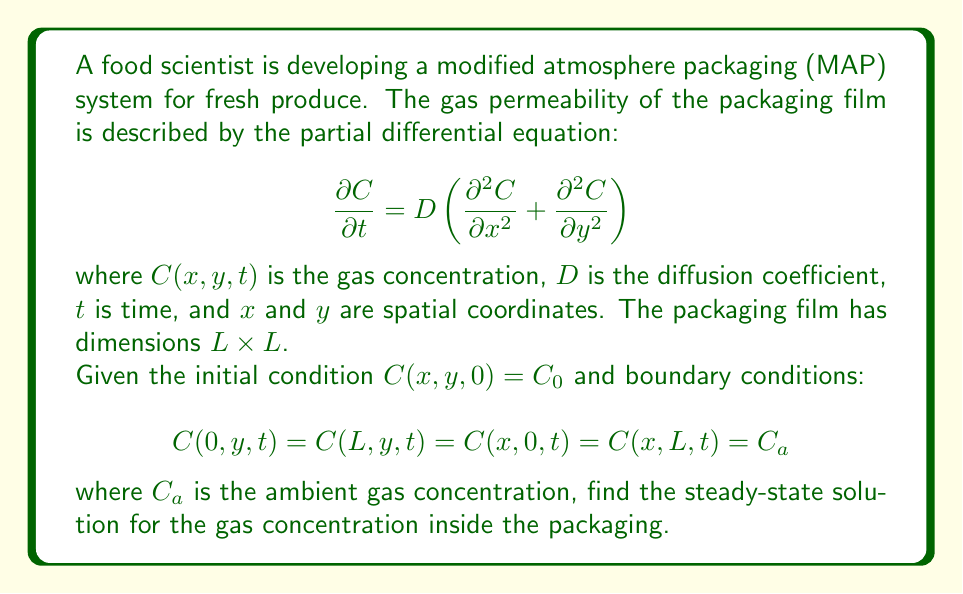Can you solve this math problem? To solve this problem, we need to follow these steps:

1) First, we recognize that we're looking for the steady-state solution. This means that the concentration doesn't change with time, so $\frac{\partial C}{\partial t} = 0$.

2) With this, our PDE reduces to:

   $$0 = D \left(\frac{\partial^2 C}{\partial x^2} + \frac{\partial^2 C}{\partial y^2}\right)$$

   or simply:

   $$\frac{\partial^2 C}{\partial x^2} + \frac{\partial^2 C}{\partial y^2} = 0$$

   This is the Laplace equation in two dimensions.

3) Given the boundary conditions, which are the same on all sides of the square packaging, we can use the method of separation of variables.

4) We assume a solution of the form $C(x,y) = X(x)Y(y)$.

5) Substituting this into our equation:

   $$X''(x)Y(y) + X(x)Y''(y) = 0$$

6) Dividing by $X(x)Y(y)$:

   $$\frac{X''(x)}{X(x)} + \frac{Y''(y)}{Y(y)} = 0$$

7) For this to be true for all $x$ and $y$, both terms must be constant. Let's call this constant $-k^2$:

   $$\frac{X''(x)}{X(x)} = -k^2, \quad \frac{Y''(y)}{Y(y)} = k^2$$

8) These lead to the general solutions:

   $$X(x) = A \cos(kx) + B \sin(kx)$$
   $$Y(y) = C \cosh(ky) + D \sinh(ky)$$

9) Applying the boundary conditions:

   At $x = 0$ and $x = L$: $C(0,y) = C(L,y) = C_a$
   At $y = 0$ and $y = L$: $C(x,0) = C(x,L) = C_a$

10) These conditions are satisfied when $k = 0$, which simplifies our solution to:

    $$C(x,y) = \text{constant} = C_a$$

Therefore, the steady-state solution is a constant concentration equal to the ambient concentration throughout the packaging.
Answer: The steady-state solution for the gas concentration inside the packaging is $C(x,y) = C_a$, where $C_a$ is the ambient gas concentration. 